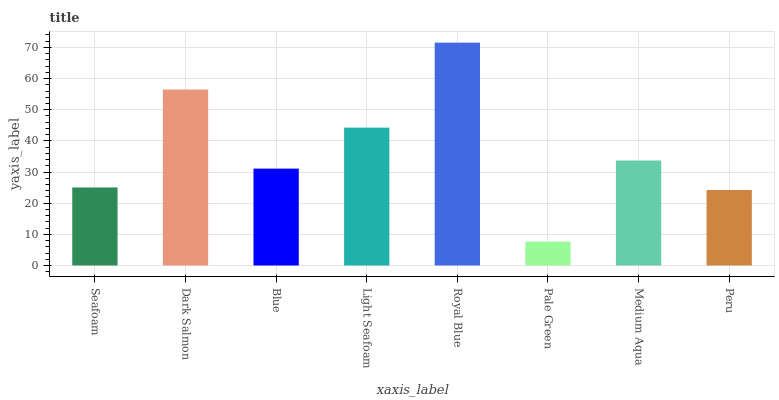Is Pale Green the minimum?
Answer yes or no. Yes. Is Royal Blue the maximum?
Answer yes or no. Yes. Is Dark Salmon the minimum?
Answer yes or no. No. Is Dark Salmon the maximum?
Answer yes or no. No. Is Dark Salmon greater than Seafoam?
Answer yes or no. Yes. Is Seafoam less than Dark Salmon?
Answer yes or no. Yes. Is Seafoam greater than Dark Salmon?
Answer yes or no. No. Is Dark Salmon less than Seafoam?
Answer yes or no. No. Is Medium Aqua the high median?
Answer yes or no. Yes. Is Blue the low median?
Answer yes or no. Yes. Is Peru the high median?
Answer yes or no. No. Is Medium Aqua the low median?
Answer yes or no. No. 